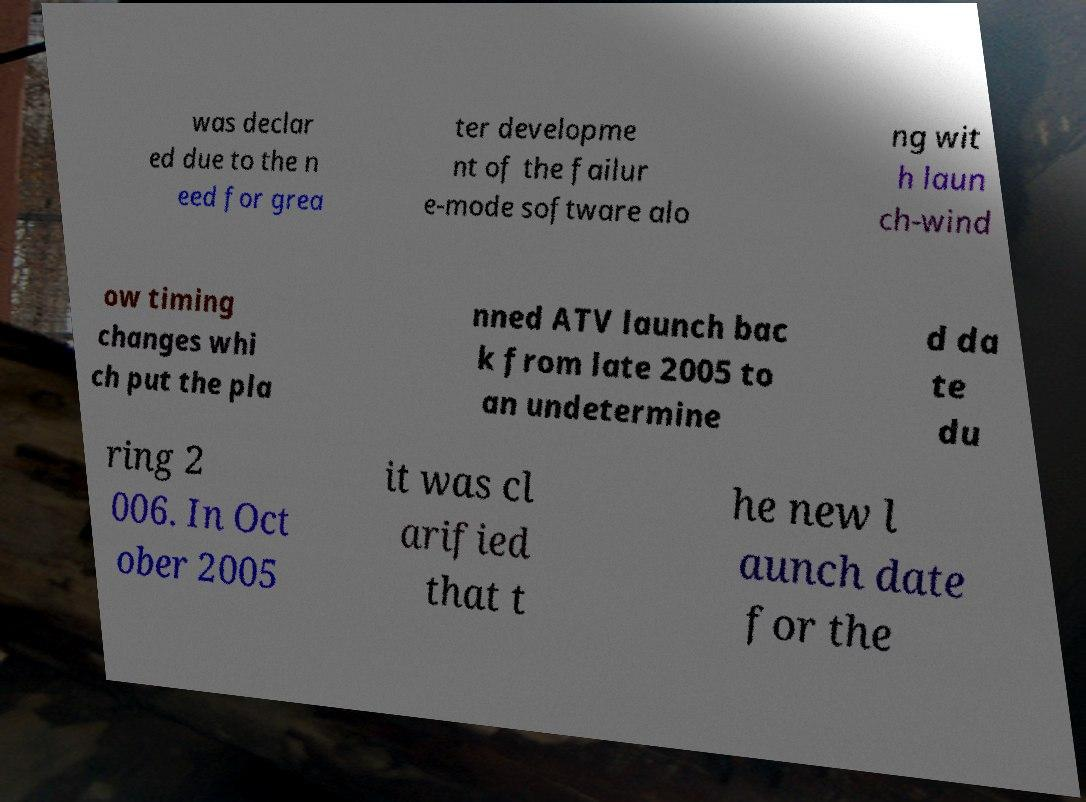Please read and relay the text visible in this image. What does it say? was declar ed due to the n eed for grea ter developme nt of the failur e-mode software alo ng wit h laun ch-wind ow timing changes whi ch put the pla nned ATV launch bac k from late 2005 to an undetermine d da te du ring 2 006. In Oct ober 2005 it was cl arified that t he new l aunch date for the 